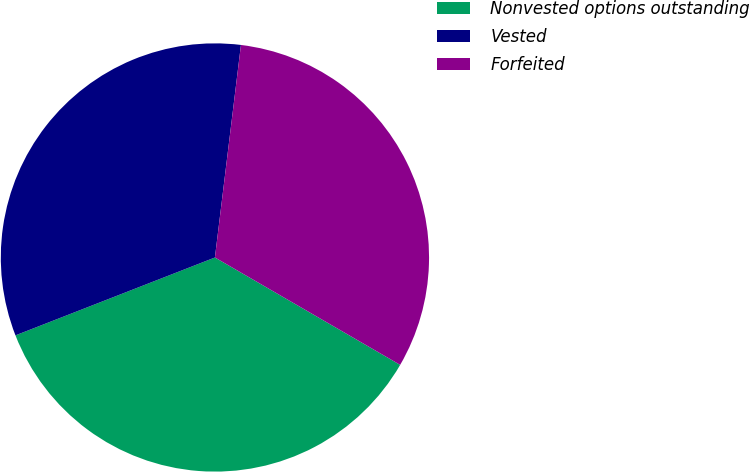Convert chart to OTSL. <chart><loc_0><loc_0><loc_500><loc_500><pie_chart><fcel>Nonvested options outstanding<fcel>Vested<fcel>Forfeited<nl><fcel>35.71%<fcel>32.86%<fcel>31.42%<nl></chart> 